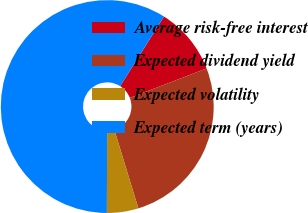<chart> <loc_0><loc_0><loc_500><loc_500><pie_chart><fcel>Average risk-free interest<fcel>Expected dividend yield<fcel>Expected volatility<fcel>Expected term (years)<nl><fcel>10.22%<fcel>26.11%<fcel>4.78%<fcel>58.89%<nl></chart> 